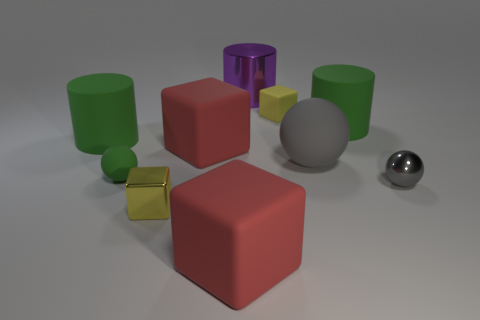Subtract all red spheres. How many green cylinders are left? 2 Subtract all yellow matte blocks. How many blocks are left? 3 Subtract 1 cylinders. How many cylinders are left? 2 Subtract all cubes. How many objects are left? 6 Subtract all cyan cubes. Subtract all brown cylinders. How many cubes are left? 4 Subtract all small blue metallic things. Subtract all metallic cylinders. How many objects are left? 9 Add 5 small yellow metal cubes. How many small yellow metal cubes are left? 6 Add 3 tiny yellow rubber blocks. How many tiny yellow rubber blocks exist? 4 Subtract 0 blue balls. How many objects are left? 10 